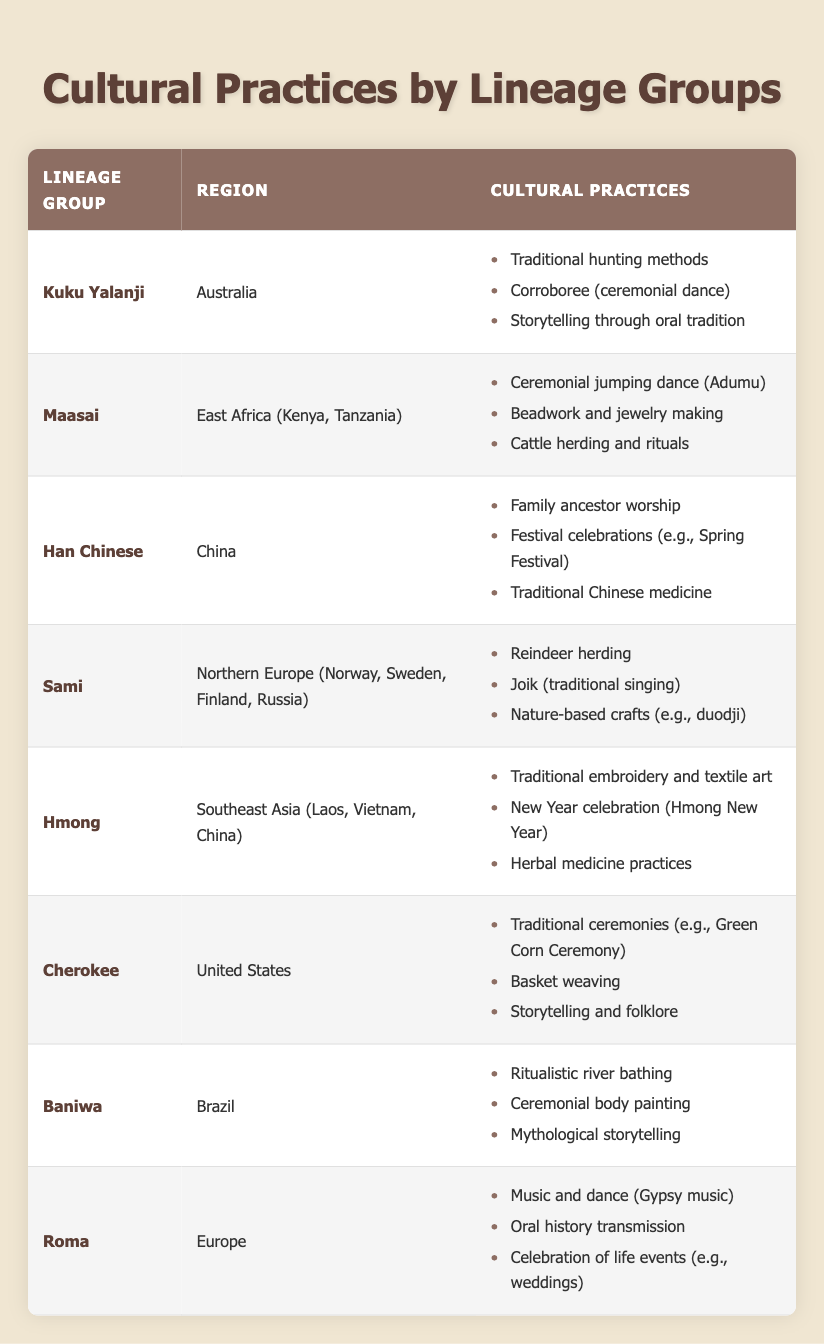What cultural practices are associated with the Kuku Yalanji lineage group? The Kuku Yalanji lineage group is associated with three specific cultural practices: traditional hunting methods, corroboree (ceremonial dance), and storytelling through oral tradition. These practices can be found in the relevant row of the table under the Kuku Yalanji entry.
Answer: Traditional hunting methods, corroboree (ceremonial dance), storytelling through oral tradition Which lineage group from Southeast Asia practices herbal medicine? The Hmong lineage group from Southeast Asia is noted for practicing herbal medicine, as indicated in their row where this practice is listed alongside traditional embroidery and textile art, and the New Year celebration.
Answer: Hmong Does the Cherokee lineage group engage in basket weaving? Yes, the Cherokee lineage group does engage in basket weaving, as confirmed in their row where basket weaving is explicitly mentioned as one of their cultural practices.
Answer: Yes How many cultural practices are associated with the Maasai lineage group? The Maasai lineage group has three cultural practices listed: ceremonial jumping dance (Adumu), beadwork and jewelry making, and cattle herding and rituals. Counting these practices gives a total of three.
Answer: Three Which lineage groups have storytelling as a cultural practice? The Kuku Yalanji, Cherokee, and Baniwa lineage groups all have storytelling listed as a cultural practice. The Kuku Yalanji engage in storytelling through oral tradition, the Cherokee engage in storytelling and folklore, and the Baniwa practice mythological storytelling. This means that there are three lineage groups.
Answer: Kuku Yalanji, Cherokee, Baniwa What percentage of the lineage groups listed in the table are from America? There are 8 lineage groups in total, and 2 of them (Cherokee) are from America. To find the percentage, we calculate (2/8) * 100%, which equals 25%. Therefore, 25% of the lineage groups are from America.
Answer: 25% Which cultural practice is unique to the Sami lineage group? The Sami lineage group exhibits reindeer herding as a cultural practice, which is not mentioned under any other lineage group in the table. This unique practice is only associated with the Sami.
Answer: Reindeer herding Are there any lineage groups that practice both music and dance? Yes, the Roma lineage group practices both music and dance, specifically through Gypsy music and celebrations of life events which often include dancing. Additionally, the Kuku Yalanji also include ceremonial dance (corroboree) as part of their cultural practices.
Answer: Yes 